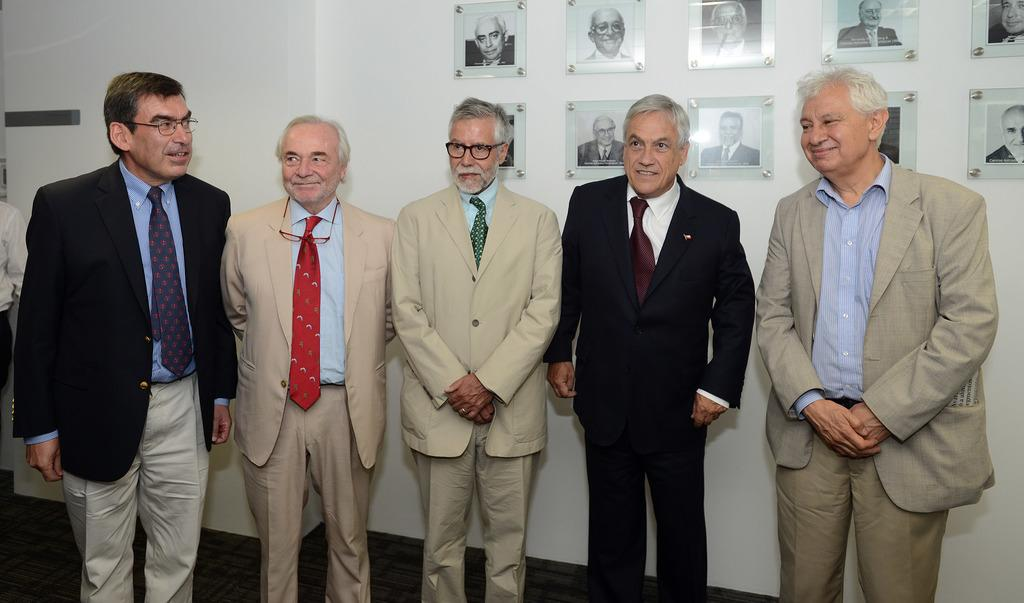What is the color of the wall in the image? The wall in the image is white. What can be seen hanging on the wall? There are photo frames in the image. Are there any people present in the image? Yes, there are people in the image. How many snakes are crawling on the wall in the image? There are no snakes present in the image; it only features a white wall with photo frames and people. 